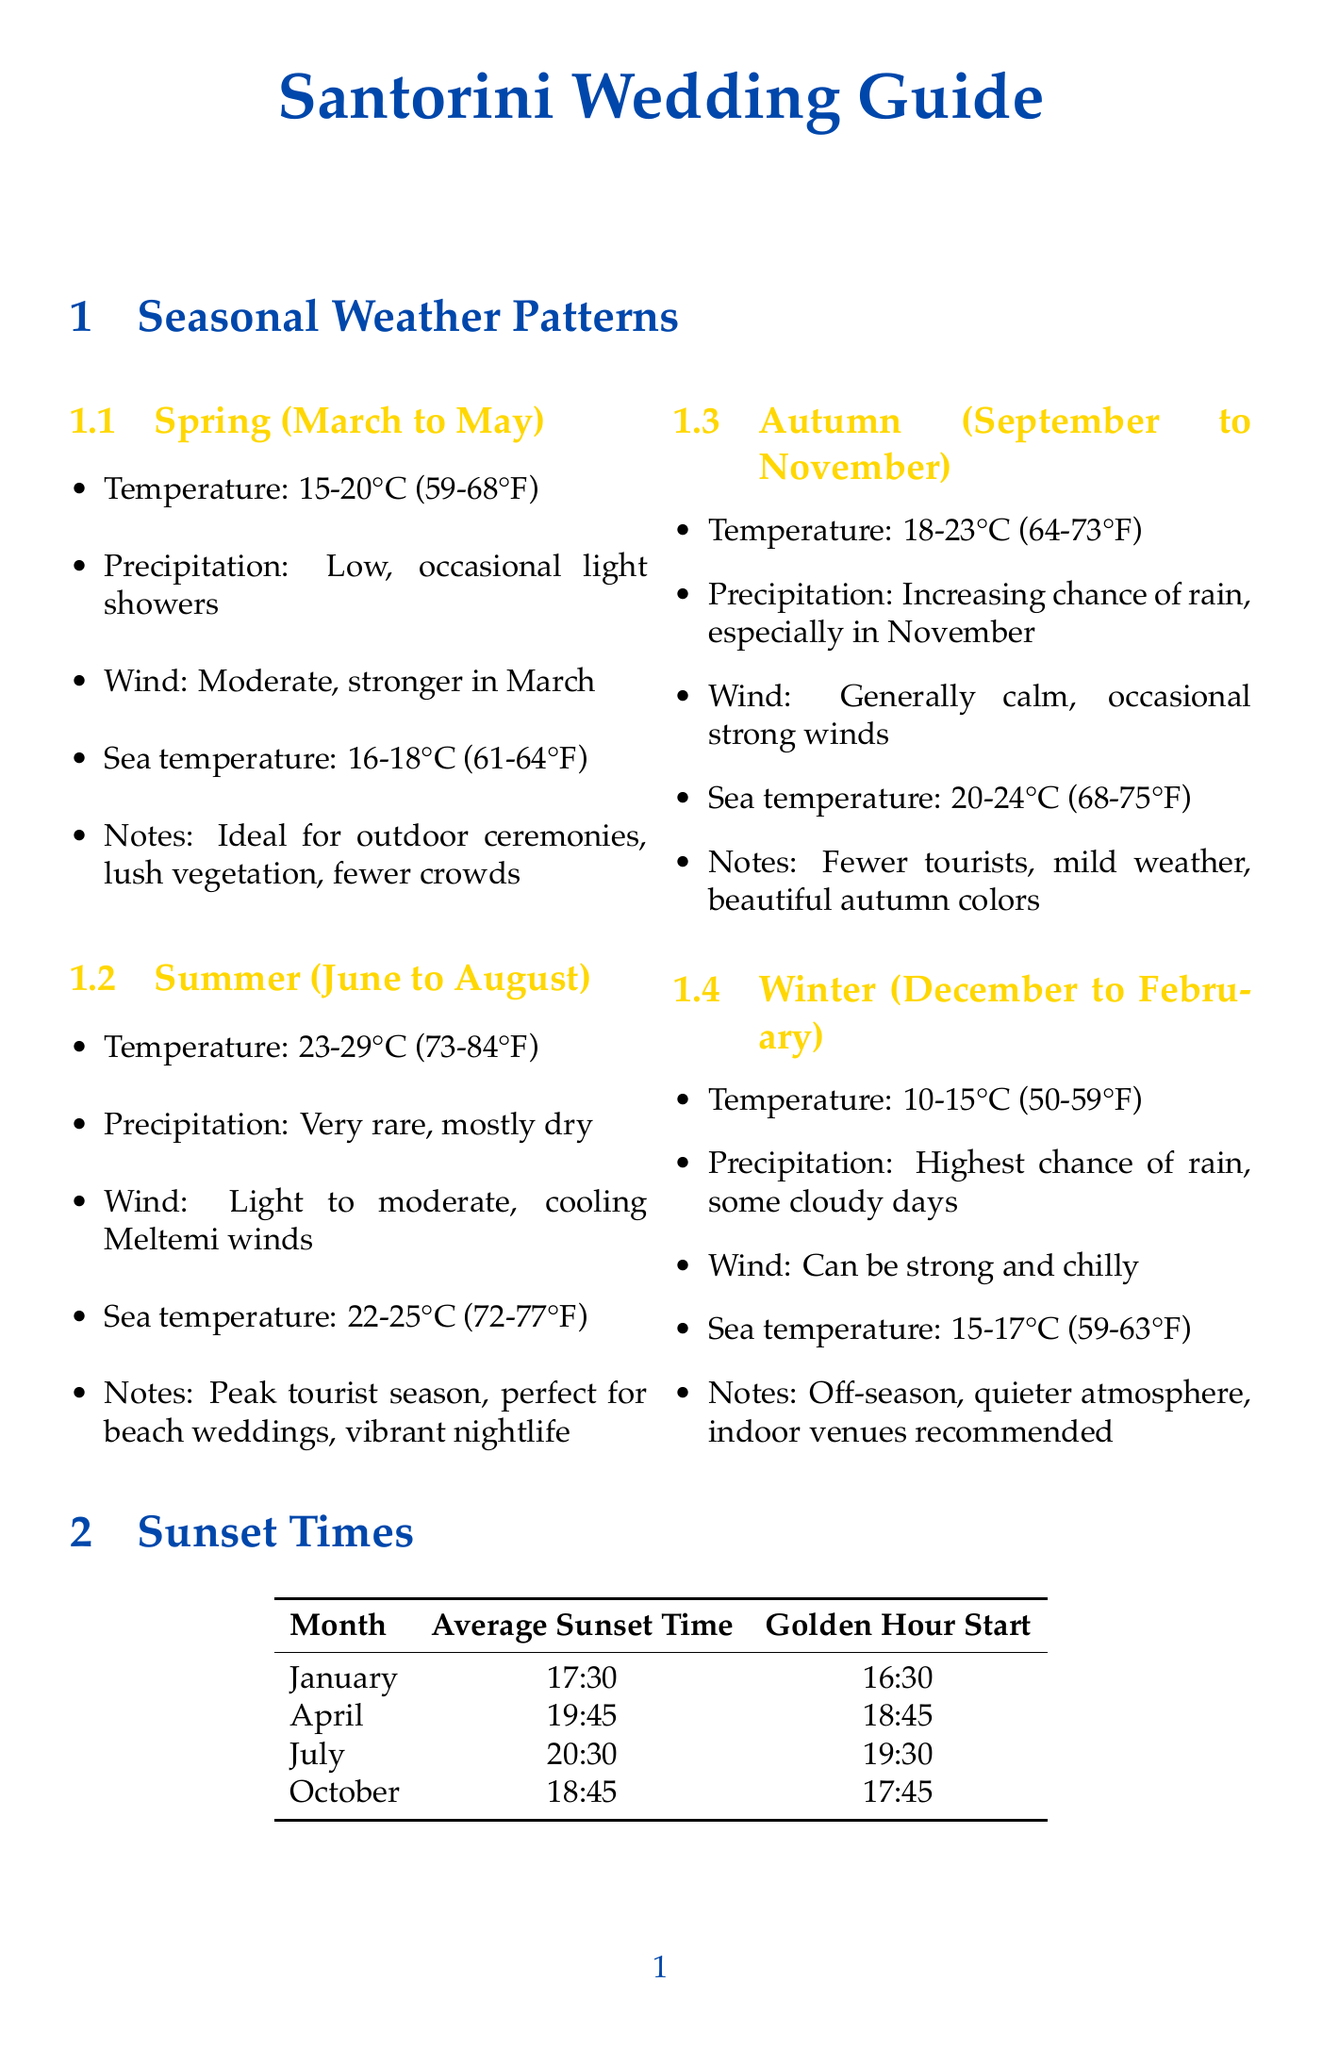What is the average temperature in summer? The average temperature in summer is given as 23-29°C (73-84°F).
Answer: 23-29°C (73-84°F) What is the best time for photographs at Akrotiri Lighthouse? The document states that sunset is the best time for photographs at Akrotiri Lighthouse.
Answer: Sunset How many photography tips are provided in the document? The document lists four photography tips in the Photography Tips section.
Answer: 4 What month has the earliest average sunset time? According to the sunset times, January has the earliest average sunset time at 17:30.
Answer: January What is the special feature of Grace Santorini? The special feature of Grace Santorini is the champagne lounge and in-house wedding planner.
Answer: Champagne lounge, in-house wedding planner During which season is there the highest chance of rain? The document indicates that winter (December to February) has the highest chance of rain.
Answer: Winter What are the average sea temperatures in autumn? The average sea temperature during autumn is given as 20-24°C (68-75°F).
Answer: 20-24°C (68-75°F) What is a key feature of Santo Wines Winery for photography? The key feature of Santo Wines Winery for photography is caldera views and a wine tasting experience.
Answer: Caldera views, wine tasting experience 